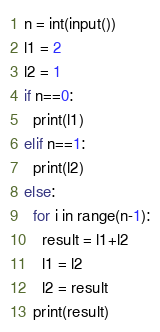<code> <loc_0><loc_0><loc_500><loc_500><_Python_>n = int(input())
l1 = 2
l2 = 1
if n==0:
  print(l1)
elif n==1:
  print(l2)
else:
  for i in range(n-1):
    result = l1+l2
    l1 = l2
    l2 = result
  print(result)</code> 